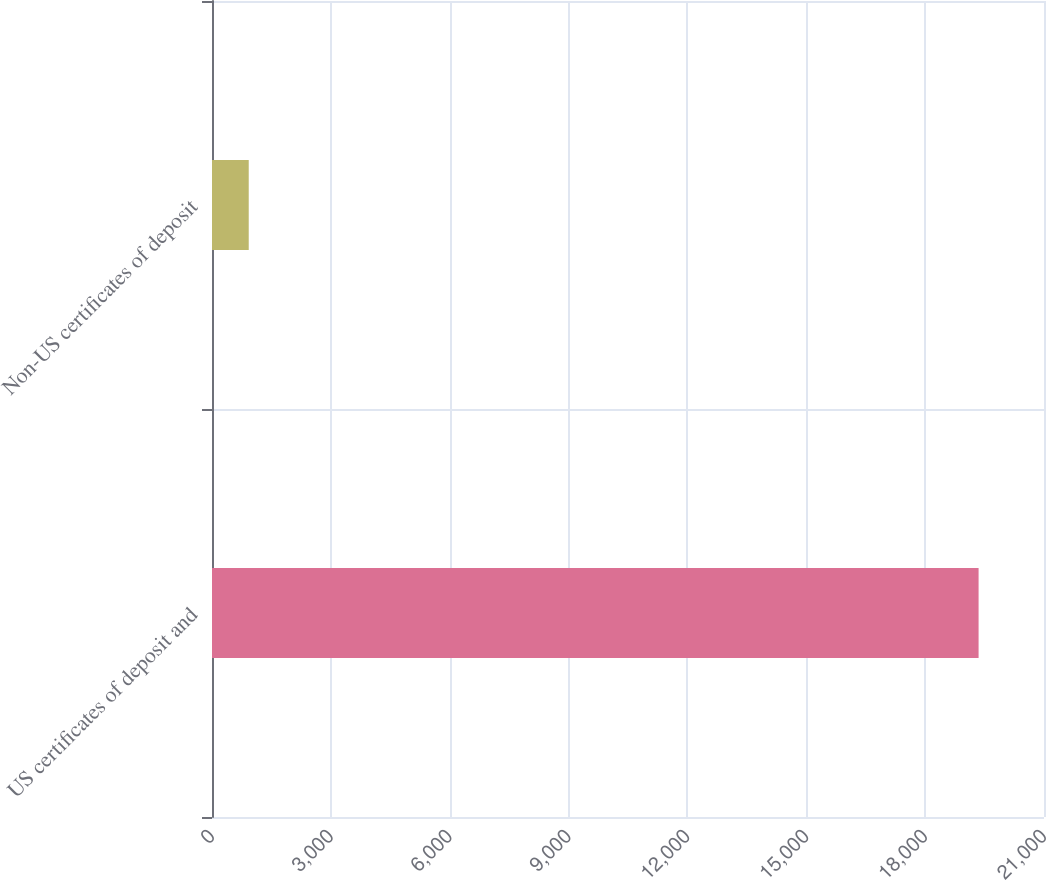Convert chart to OTSL. <chart><loc_0><loc_0><loc_500><loc_500><bar_chart><fcel>US certificates of deposit and<fcel>Non-US certificates of deposit<nl><fcel>19349<fcel>927<nl></chart> 